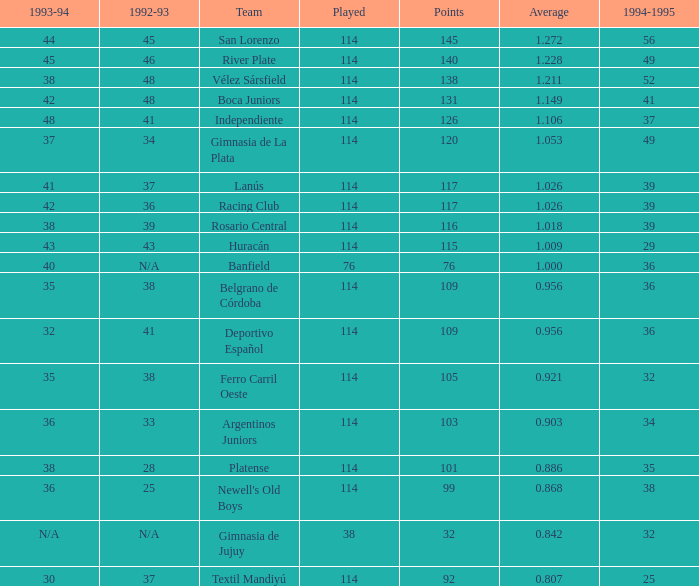Name the most played 114.0. 